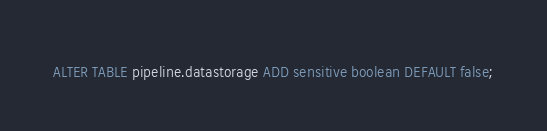Convert code to text. <code><loc_0><loc_0><loc_500><loc_500><_SQL_>ALTER TABLE pipeline.datastorage ADD sensitive boolean DEFAULT false;</code> 